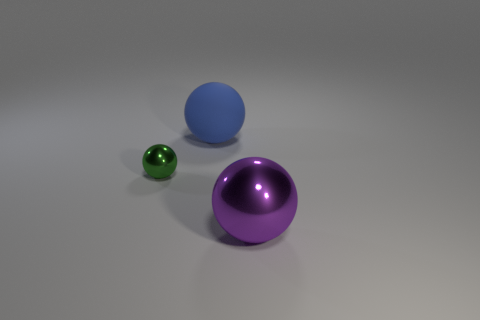What number of blue objects are left of the thing that is in front of the small green metal thing?
Give a very brief answer. 1. What number of spheres are behind the tiny thing and in front of the green metal thing?
Your answer should be very brief. 0. How many things are either tiny brown metal cylinders or things left of the big purple object?
Provide a succinct answer. 2. There is another purple object that is the same material as the tiny thing; what size is it?
Keep it short and to the point. Large. There is a metal thing to the left of the thing behind the small green ball; what is its shape?
Offer a very short reply. Sphere. What number of green objects are either small objects or big shiny objects?
Your answer should be very brief. 1. Are there any metallic objects that are on the left side of the ball right of the big blue ball that is behind the purple sphere?
Offer a very short reply. Yes. Are there any other things that are the same material as the purple object?
Keep it short and to the point. Yes. How many small objects are either purple things or blue rubber objects?
Offer a terse response. 0. Do the shiny thing on the left side of the big blue rubber ball and the big purple object have the same shape?
Offer a terse response. Yes. 